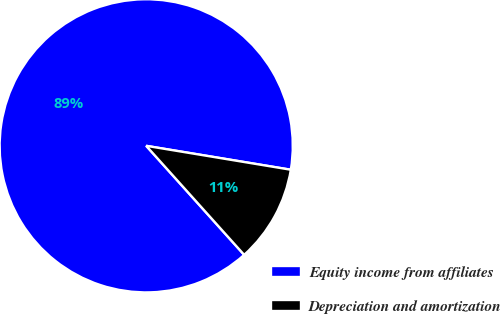Convert chart. <chart><loc_0><loc_0><loc_500><loc_500><pie_chart><fcel>Equity income from affiliates<fcel>Depreciation and amortization<nl><fcel>89.26%<fcel>10.74%<nl></chart> 